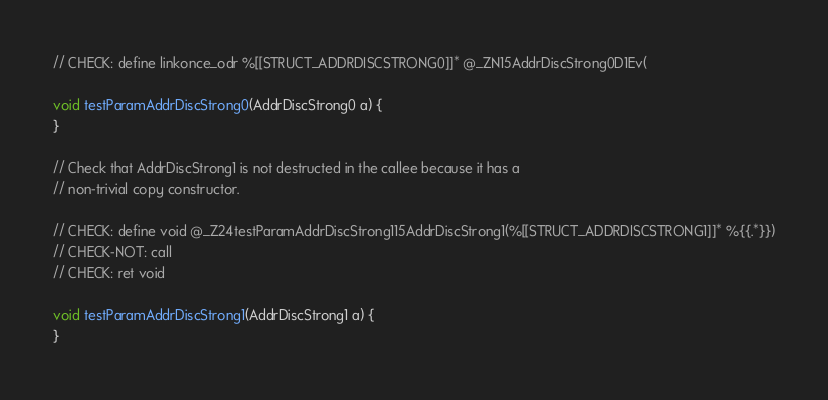<code> <loc_0><loc_0><loc_500><loc_500><_ObjectiveC_>
// CHECK: define linkonce_odr %[[STRUCT_ADDRDISCSTRONG0]]* @_ZN15AddrDiscStrong0D1Ev(

void testParamAddrDiscStrong0(AddrDiscStrong0 a) {
}

// Check that AddrDiscStrong1 is not destructed in the callee because it has a
// non-trivial copy constructor.

// CHECK: define void @_Z24testParamAddrDiscStrong115AddrDiscStrong1(%[[STRUCT_ADDRDISCSTRONG1]]* %{{.*}})
// CHECK-NOT: call
// CHECK: ret void

void testParamAddrDiscStrong1(AddrDiscStrong1 a) {
}
</code> 